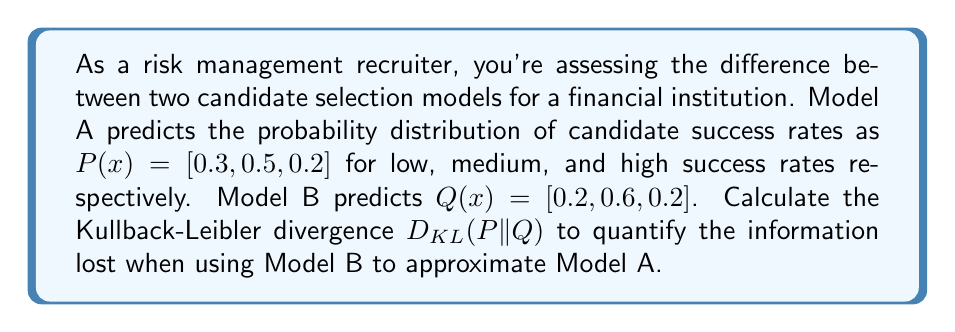Can you solve this math problem? To solve this problem, we'll use the Kullback-Leibler divergence formula:

$$D_{KL}(P||Q) = \sum_{i} P(x_i) \log\left(\frac{P(x_i)}{Q(x_i)}\right)$$

Let's calculate each term:

1) For $x_1$ (low success rate):
   $P(x_1) = 0.3$, $Q(x_1) = 0.2$
   $0.3 \log\left(\frac{0.3}{0.2}\right) = 0.3 \log(1.5) \approx 0.0621$

2) For $x_2$ (medium success rate):
   $P(x_2) = 0.5$, $Q(x_2) = 0.6$
   $0.5 \log\left(\frac{0.5}{0.6}\right) = 0.5 \log(0.8333) \approx -0.0405$

3) For $x_3$ (high success rate):
   $P(x_3) = 0.2$, $Q(x_3) = 0.2$
   $0.2 \log\left(\frac{0.2}{0.2}\right) = 0.2 \log(1) = 0$

Now, sum these terms:

$$D_{KL}(P||Q) = 0.0621 + (-0.0405) + 0 = 0.0216$$

This result indicates the information lost when using Model B to approximate Model A in bits (assuming log base 2).
Answer: The Kullback-Leibler divergence $D_{KL}(P||Q)$ is approximately 0.0216 bits. 